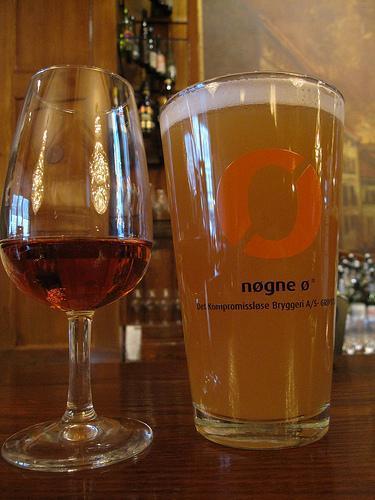How many glasses of wine are there?
Give a very brief answer. 1. 